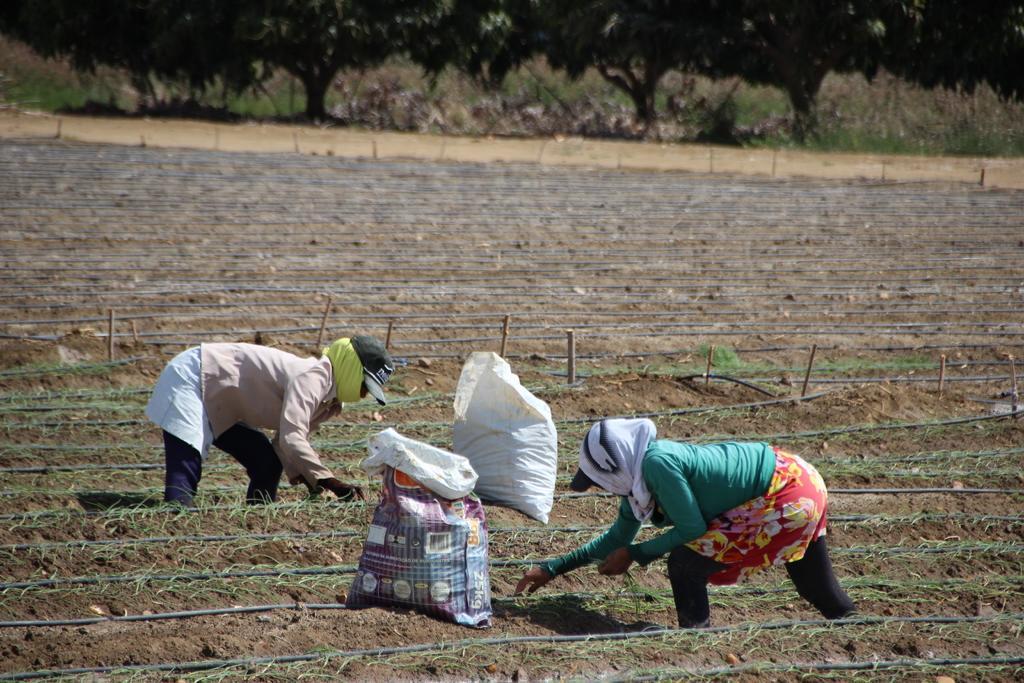Describe this image in one or two sentences. In this image there are two persons before them there are two bags which are on the land. There are few plants on the land which are having few pipes on it. A person wearing a green shirt is wearing a cap which is covered with cloth. Behind them there is fence. There are few trees and grass are on the land. 